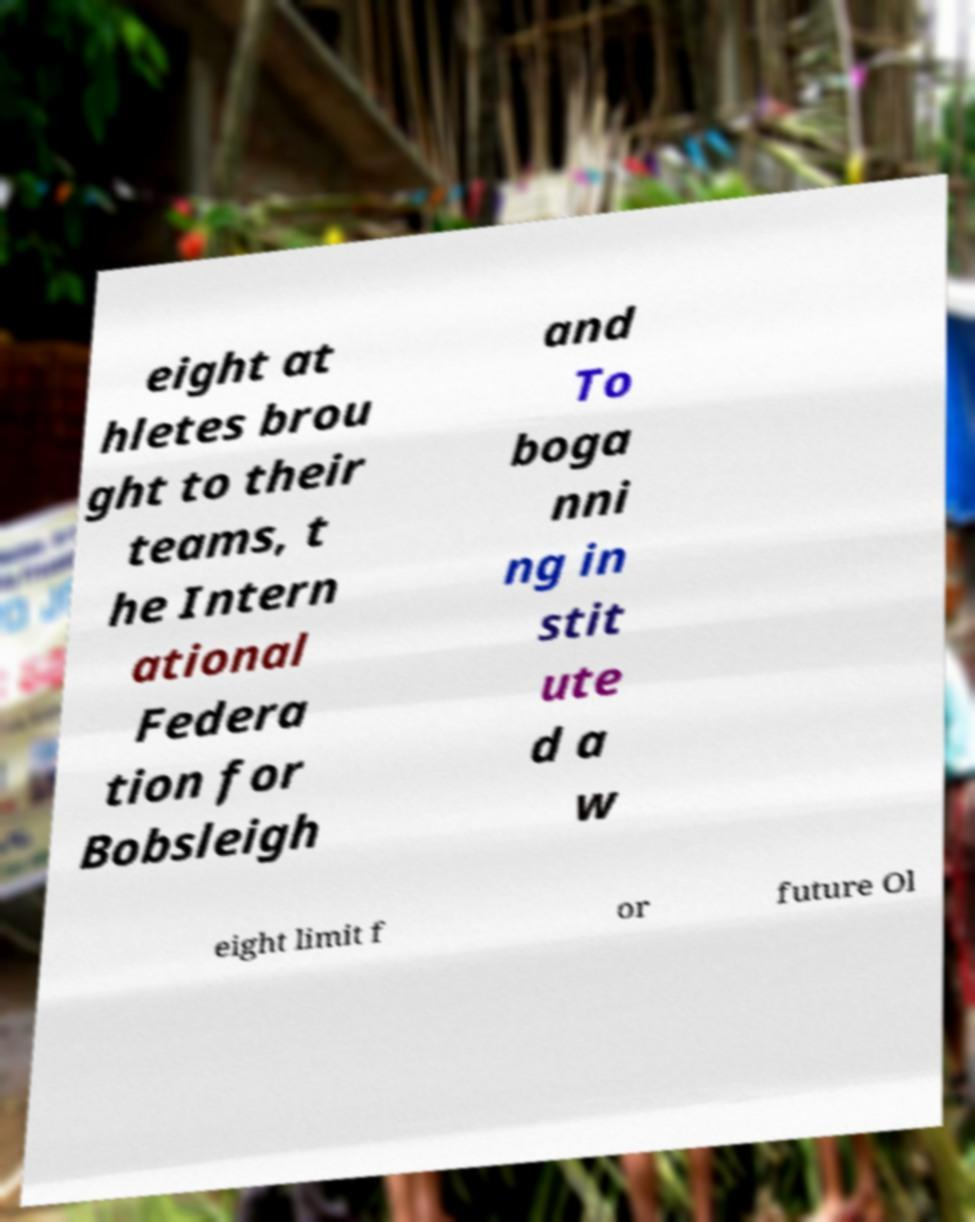Can you read and provide the text displayed in the image?This photo seems to have some interesting text. Can you extract and type it out for me? eight at hletes brou ght to their teams, t he Intern ational Federa tion for Bobsleigh and To boga nni ng in stit ute d a w eight limit f or future Ol 